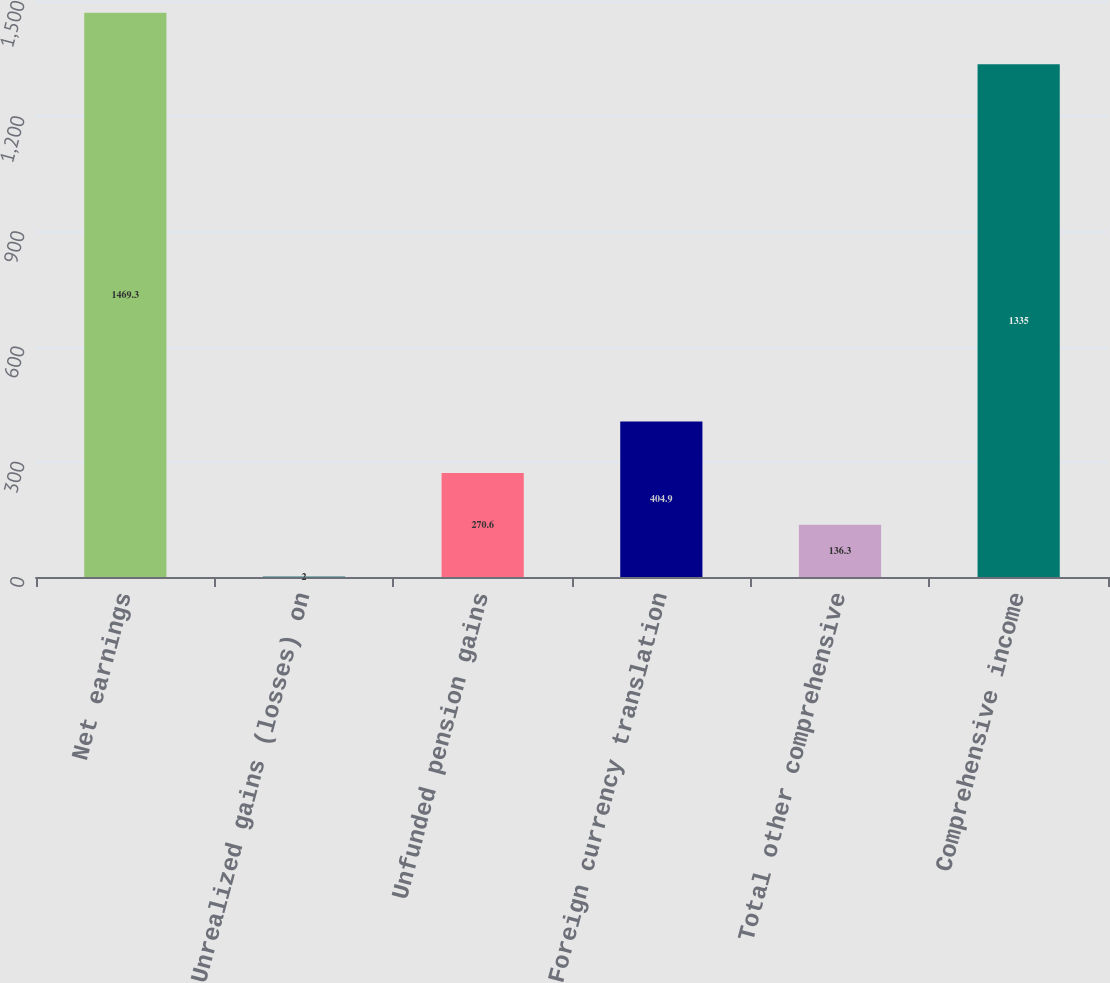<chart> <loc_0><loc_0><loc_500><loc_500><bar_chart><fcel>Net earnings<fcel>Unrealized gains (losses) on<fcel>Unfunded pension gains<fcel>Foreign currency translation<fcel>Total other comprehensive<fcel>Comprehensive income<nl><fcel>1469.3<fcel>2<fcel>270.6<fcel>404.9<fcel>136.3<fcel>1335<nl></chart> 